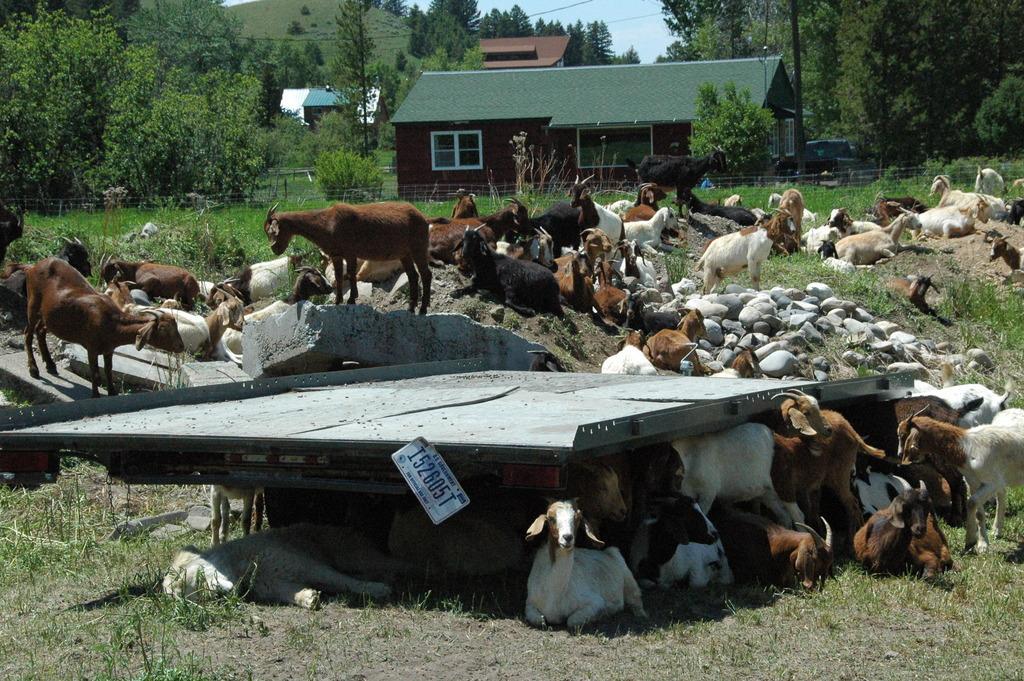Could you give a brief overview of what you see in this image? In this image I can see many animals which are in brown, black and white color. In the background I can see the houses, many trees, mountains and the sky. I can see few rocks and an ash color object. 